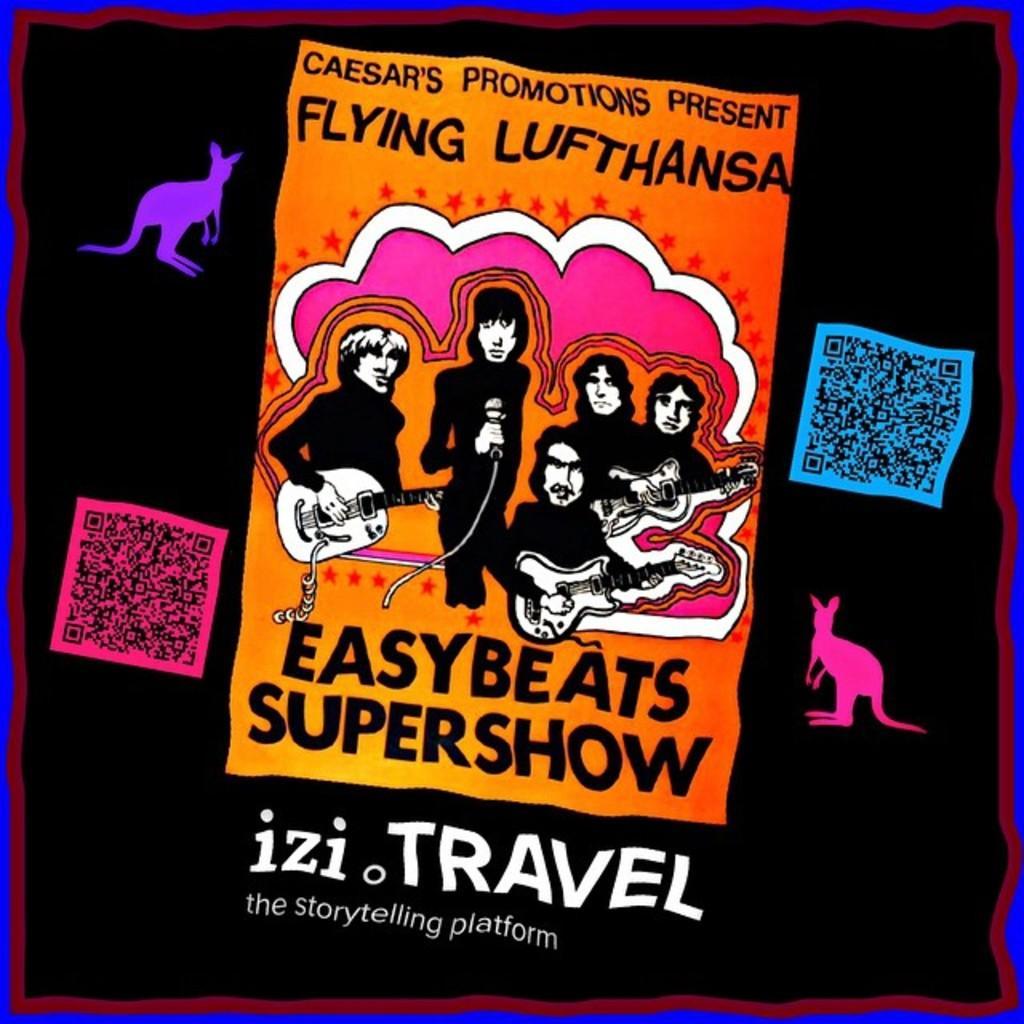How would you summarize this image in a sentence or two? This might be a poster, in this image there is a text and there are some people, guitar and animals. 